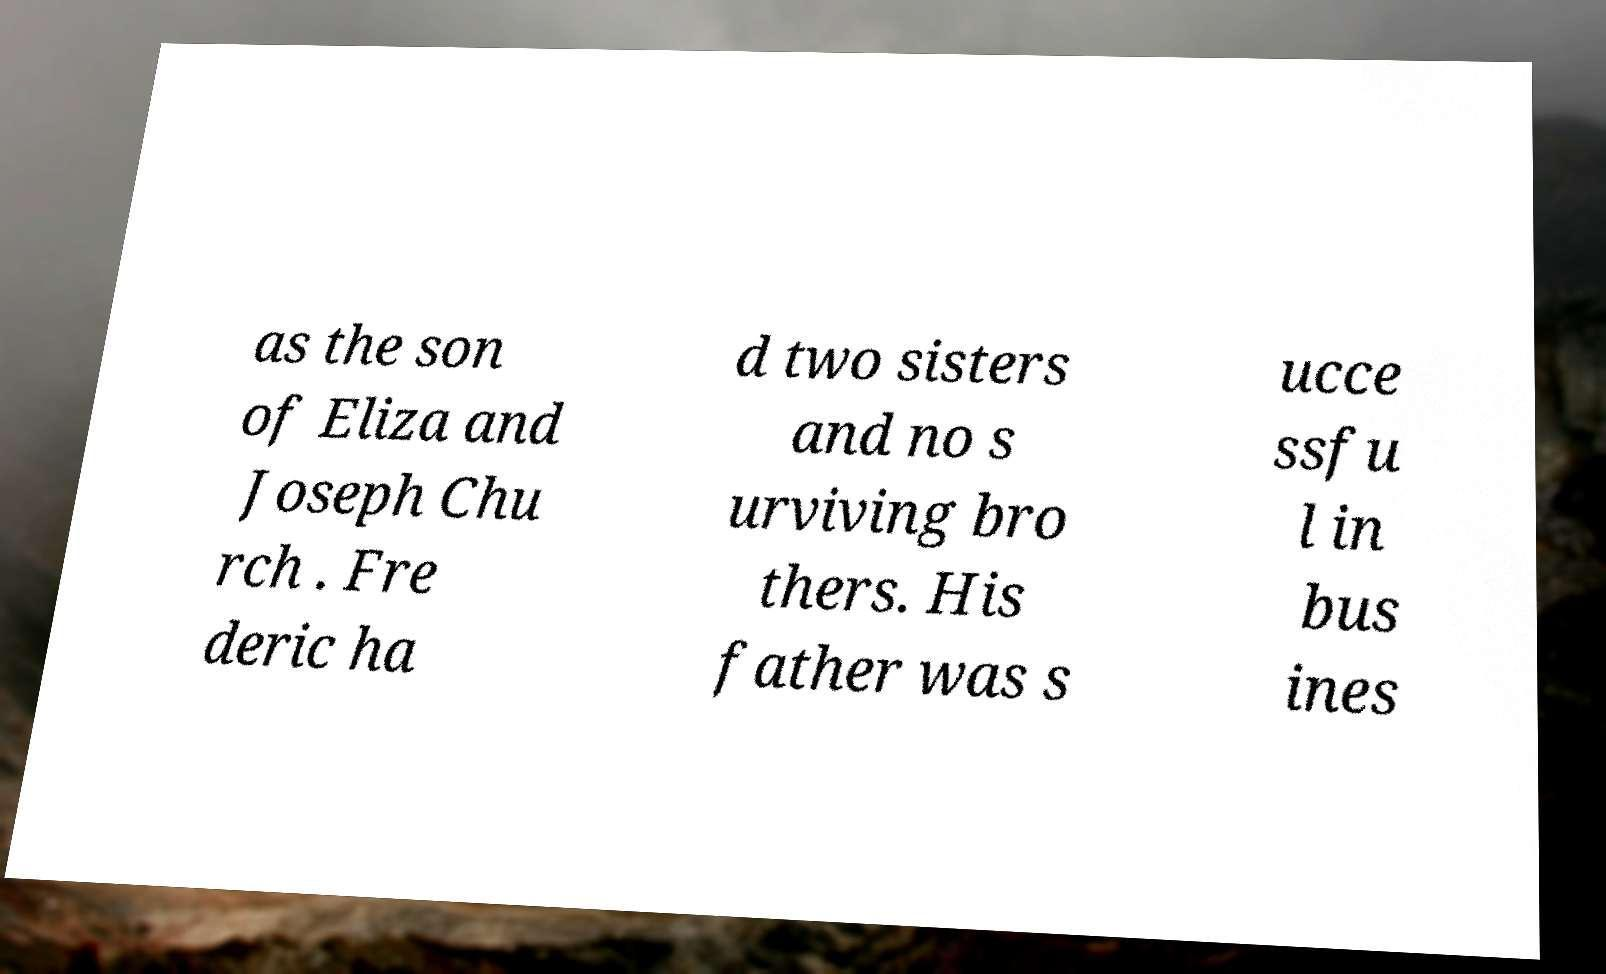Could you extract and type out the text from this image? as the son of Eliza and Joseph Chu rch . Fre deric ha d two sisters and no s urviving bro thers. His father was s ucce ssfu l in bus ines 